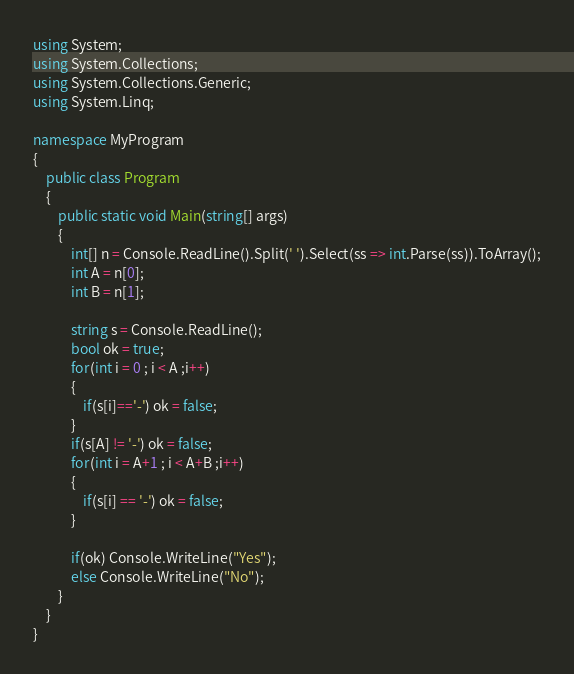Convert code to text. <code><loc_0><loc_0><loc_500><loc_500><_C#_>using System;
using System.Collections;
using System.Collections.Generic;
using System.Linq;

namespace MyProgram
{
    public class Program
    {	
        public static void Main(string[] args)
        {
            int[] n = Console.ReadLine().Split(' ').Select(ss => int.Parse(ss)).ToArray();
            int A = n[0];
            int B = n[1];
            
            string s = Console.ReadLine();
            bool ok = true;
            for(int i = 0 ; i < A ;i++)
            {
                if(s[i]=='-') ok = false;
            }
            if(s[A] != '-') ok = false;
            for(int i = A+1 ; i < A+B ;i++)
            {
                if(s[i] == '-') ok = false;
            }
            
            if(ok) Console.WriteLine("Yes");
            else Console.WriteLine("No");
        }
    }
}</code> 